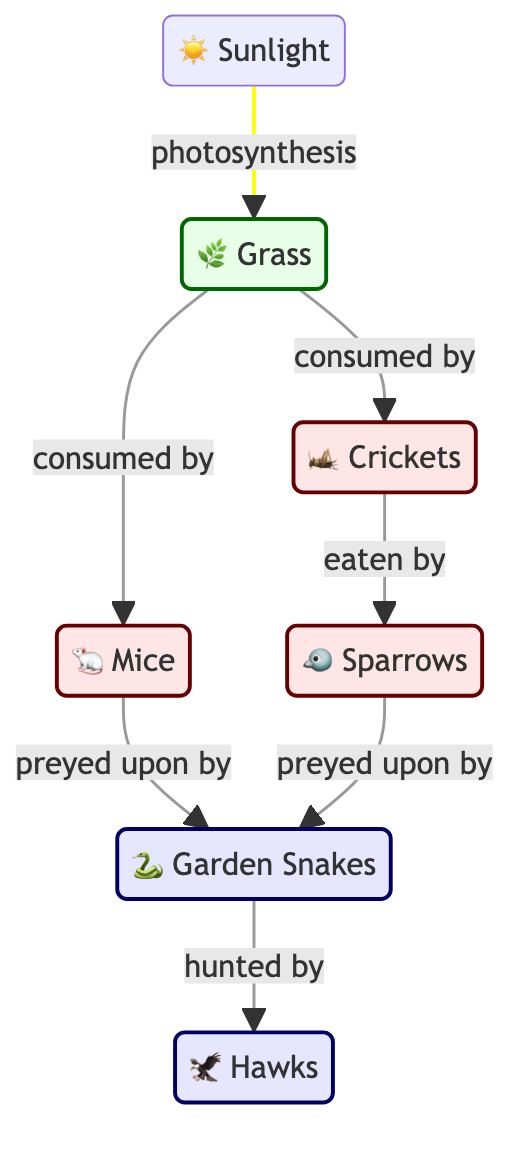What's the topmost node in the diagram? The diagram starts with sunlight at the top, which is the source of energy for the entire food chain.
Answer: Sunlight How many consumer nodes are present in the diagram? The diagram shows three consumer nodes: crickets, sparrows, and mice. By counting these, we arrive at the total number of consumer nodes.
Answer: Three Which producer is being consumed by crickets? According to the diagram, crickets feed on grass, which is the only producer identified in this part of the food chain.
Answer: Grass Who preys upon both mice and sparrows? By examining the relationships in the diagram, garden snakes are shown to prey on both mice and sparrows. The arrows indicating predation point to garden snakes from both consumer nodes.
Answer: Garden Snakes How many steps are there from grass to hawks? Starting from grass, the sequence is: grass to crickets (1), crickets to sparrows (2), sparrows to garden snakes (3), and finally garden snakes to hawks (4). Thus, there are four steps in total.
Answer: Four What consumes grass other than crickets? The diagram indicates that mice also consume grass, as an arrow points from grass to mice showing this relationship.
Answer: Mice Which animal is at the highest level of the food chain? By identifying the predator at the top of the diagram, hawks are shown as the final consumer, indicating they are at the highest level of the food chain.
Answer: Hawks How many types of predators are there in the diagram? There are two types of predators represented: garden snakes and hawks, each indicated by an arrow showing their predatory relationships.
Answer: Two What process allows grass to grow using sunlight? The diagram states that grass utilizes sunlight to perform photosynthesis, which is the fundamental process for plant growth.
Answer: Photosynthesis 